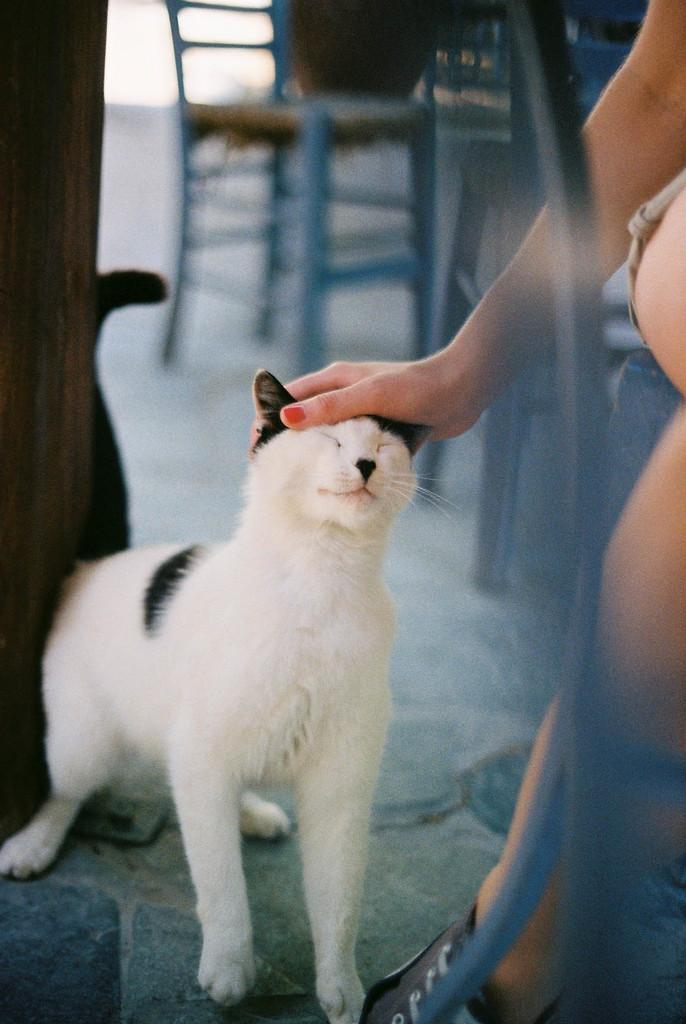What animal is located in the middle of the image? There is a cat in the middle of the image. What type of furniture is visible at the top of the image? There are chairs at the top of the image. What is the person in the image doing? A person is sitting on one of the chairs. How is the cat interacting with the person in the image? The person is holding the cat. What type of humor is the minister displaying in the image? There is no minister present in the image, and therefore no humor can be observed. 